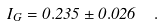<formula> <loc_0><loc_0><loc_500><loc_500>I _ { G } = 0 . 2 3 5 \pm 0 . 0 2 6 \ \ .</formula> 